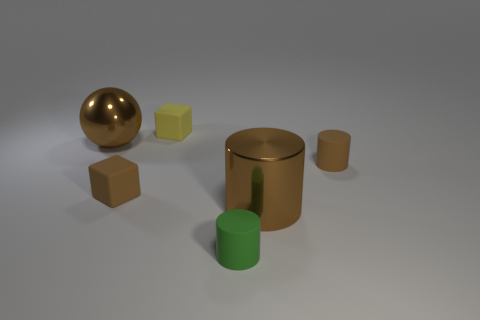How many green cylinders have the same material as the big brown cylinder?
Provide a short and direct response. 0. Is there a large purple rubber object?
Offer a terse response. No. There is a brown metal thing on the right side of the tiny green matte object; how big is it?
Offer a terse response. Large. What number of cylinders have the same color as the large shiny ball?
Make the answer very short. 2. How many cylinders are either large brown things or tiny matte things?
Your response must be concise. 3. The brown object that is both behind the metallic cylinder and right of the green object has what shape?
Offer a very short reply. Cylinder. Is there a cyan cube of the same size as the brown ball?
Give a very brief answer. No. What number of things are brown metal things that are in front of the big brown ball or small brown rubber things?
Provide a short and direct response. 3. Is the material of the green thing the same as the large brown sphere that is on the left side of the yellow matte thing?
Your response must be concise. No. What number of other things are there of the same shape as the small yellow thing?
Your answer should be very brief. 1. 